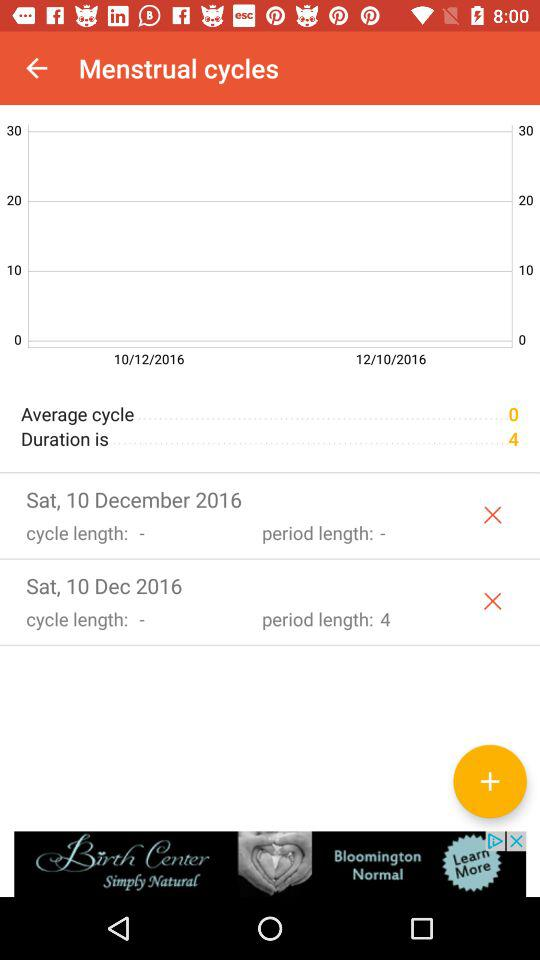What is the average cycle duration? The average cycle duration is 4. 